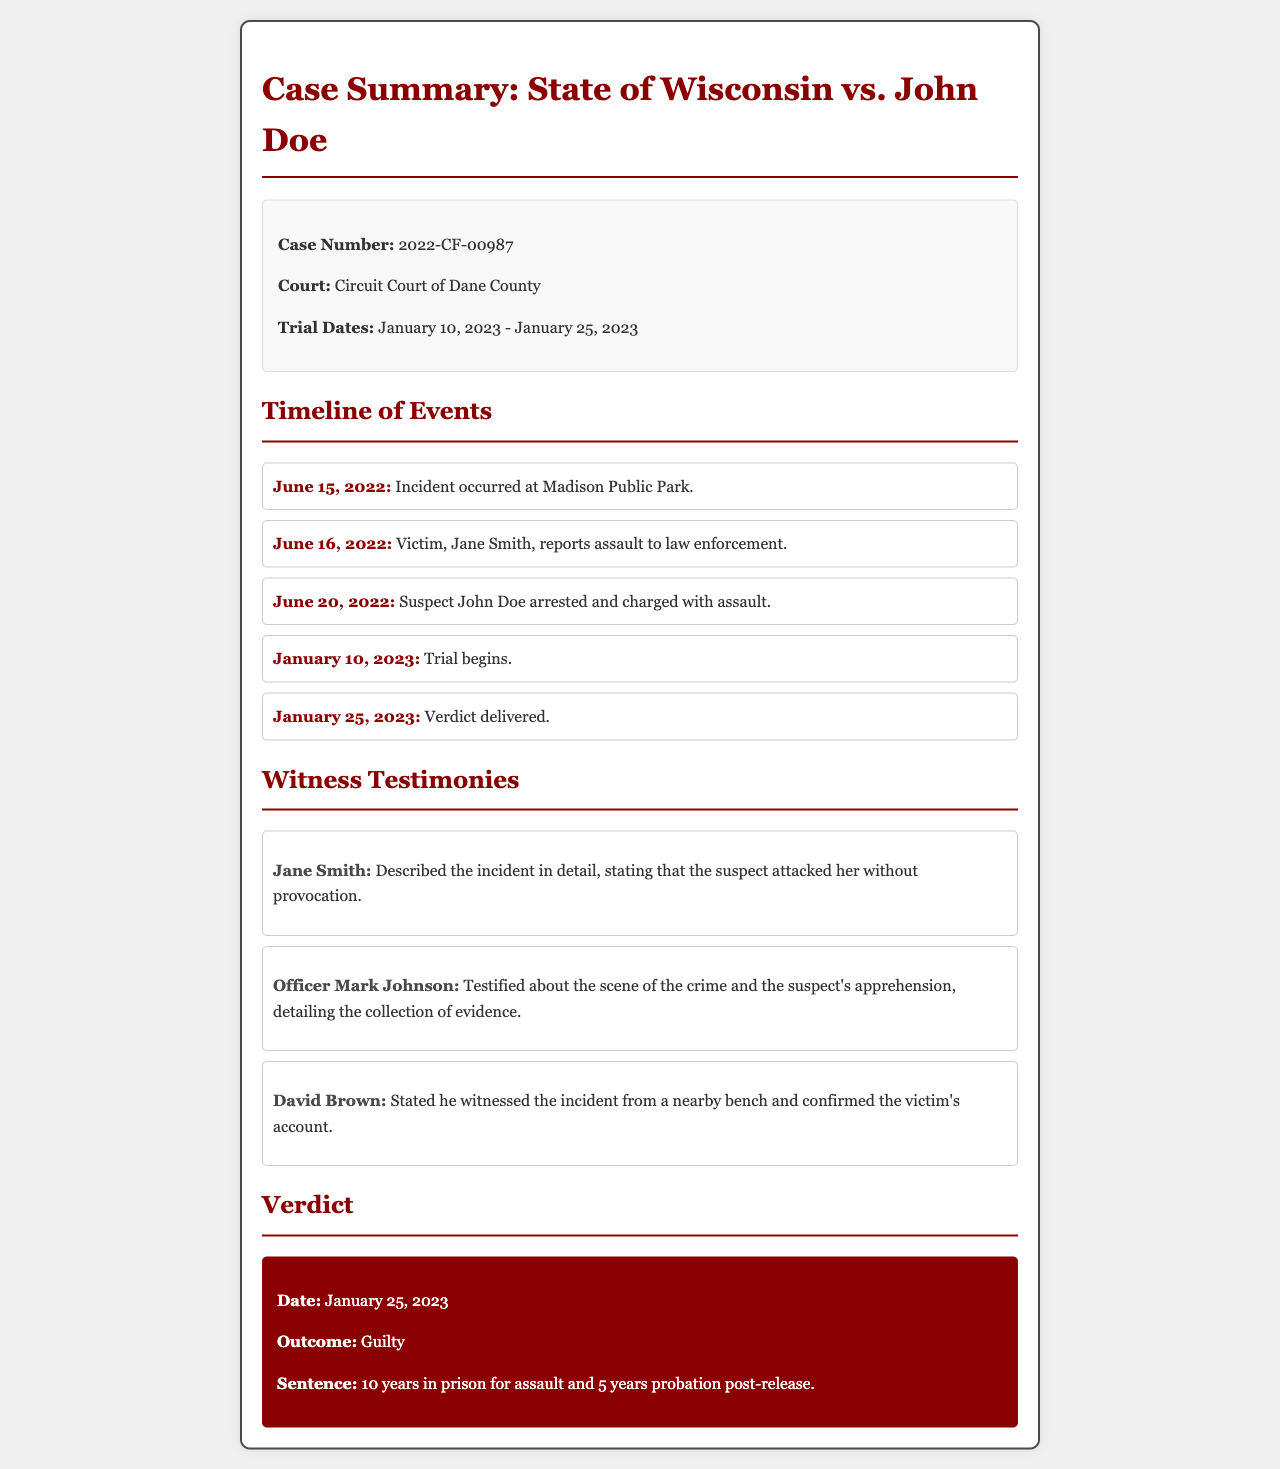What is the case number? The case number is displayed in the case info section of the document as 2022-CF-00987.
Answer: 2022-CF-00987 Who is the victim in this case? The victim's name is mentioned in the witness testimonies section as Jane Smith.
Answer: Jane Smith When did the trial begin? The trial start date is listed in the case info section as January 10, 2023.
Answer: January 10, 2023 What was the verdict delivered on? The verdict date is stated in the timeline section as January 25, 2023.
Answer: January 25, 2023 How long was the sentence for assault? The sentence details in the verdict section specify a sentence of 10 years for assault.
Answer: 10 years What type of case is being summarized? The case is summarized as a criminal case based on the document's context relating to assault.
Answer: Criminal Who testified as a witness? The witness testimonies include names, one of which is Jane Smith, who is the victim.
Answer: Jane Smith How many years of probation was assigned after release? The sentence information mentions a probation period of 5 years post-release.
Answer: 5 years What is the court where the trial was held? The court name is explicitly stated in the case info section as Circuit Court of Dane County.
Answer: Circuit Court of Dane County 